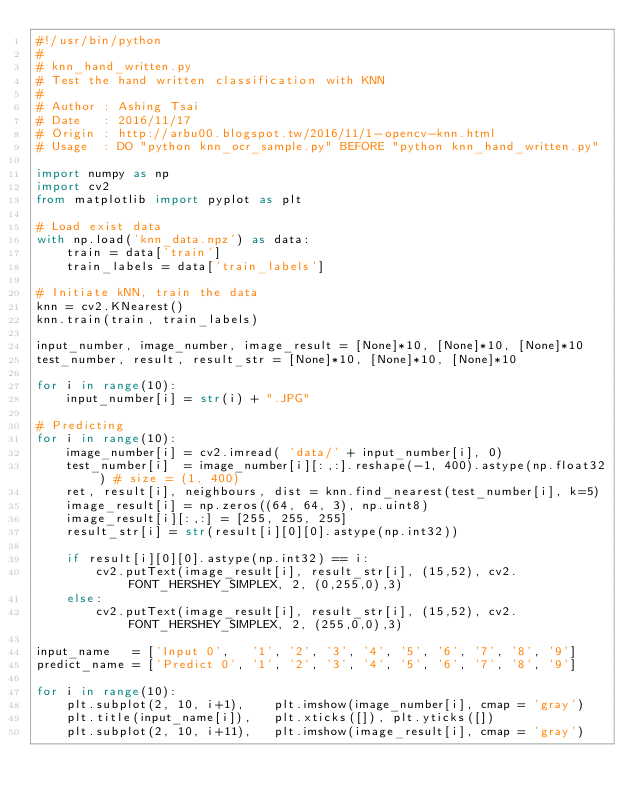<code> <loc_0><loc_0><loc_500><loc_500><_Python_>#!/usr/bin/python
#
# knn_hand_written.py
# Test the hand written classification with KNN
#
# Author : Ashing Tsai
# Date   : 2016/11/17
# Origin : http://arbu00.blogspot.tw/2016/11/1-opencv-knn.html
# Usage  : DO "python knn_ocr_sample.py" BEFORE "python knn_hand_written.py"

import numpy as np
import cv2
from matplotlib import pyplot as plt
 
# Load exist data
with np.load('knn_data.npz') as data:
    train = data['train']
    train_labels = data['train_labels']

# Initiate kNN, train the data
knn = cv2.KNearest()
knn.train(train, train_labels)
 
input_number, image_number, image_result = [None]*10, [None]*10, [None]*10
test_number, result, result_str = [None]*10, [None]*10, [None]*10

for i in range(10):
    input_number[i] = str(i) + ".JPG"

# Predicting
for i in range(10):  
    image_number[i] = cv2.imread( 'data/' + input_number[i], 0)
    test_number[i]  = image_number[i][:,:].reshape(-1, 400).astype(np.float32) # size = (1, 400)
    ret, result[i], neighbours, dist = knn.find_nearest(test_number[i], k=5)
    image_result[i] = np.zeros((64, 64, 3), np.uint8)
    image_result[i][:,:] = [255, 255, 255]
    result_str[i] = str(result[i][0][0].astype(np.int32))

    if result[i][0][0].astype(np.int32) == i:
        cv2.putText(image_result[i], result_str[i], (15,52), cv2.FONT_HERSHEY_SIMPLEX, 2, (0,255,0),3)
    else:
        cv2.putText(image_result[i], result_str[i], (15,52), cv2.FONT_HERSHEY_SIMPLEX, 2, (255,0,0),3)

input_name   = ['Input 0',   '1', '2', '3', '4', '5', '6', '7', '8', '9']
predict_name = ['Predict 0', '1', '2', '3', '4', '5', '6', '7', '8', '9']

for i in range(10):
    plt.subplot(2, 10, i+1),    plt.imshow(image_number[i], cmap = 'gray')
    plt.title(input_name[i]),   plt.xticks([]), plt.yticks([])
    plt.subplot(2, 10, i+11),   plt.imshow(image_result[i], cmap = 'gray')</code> 